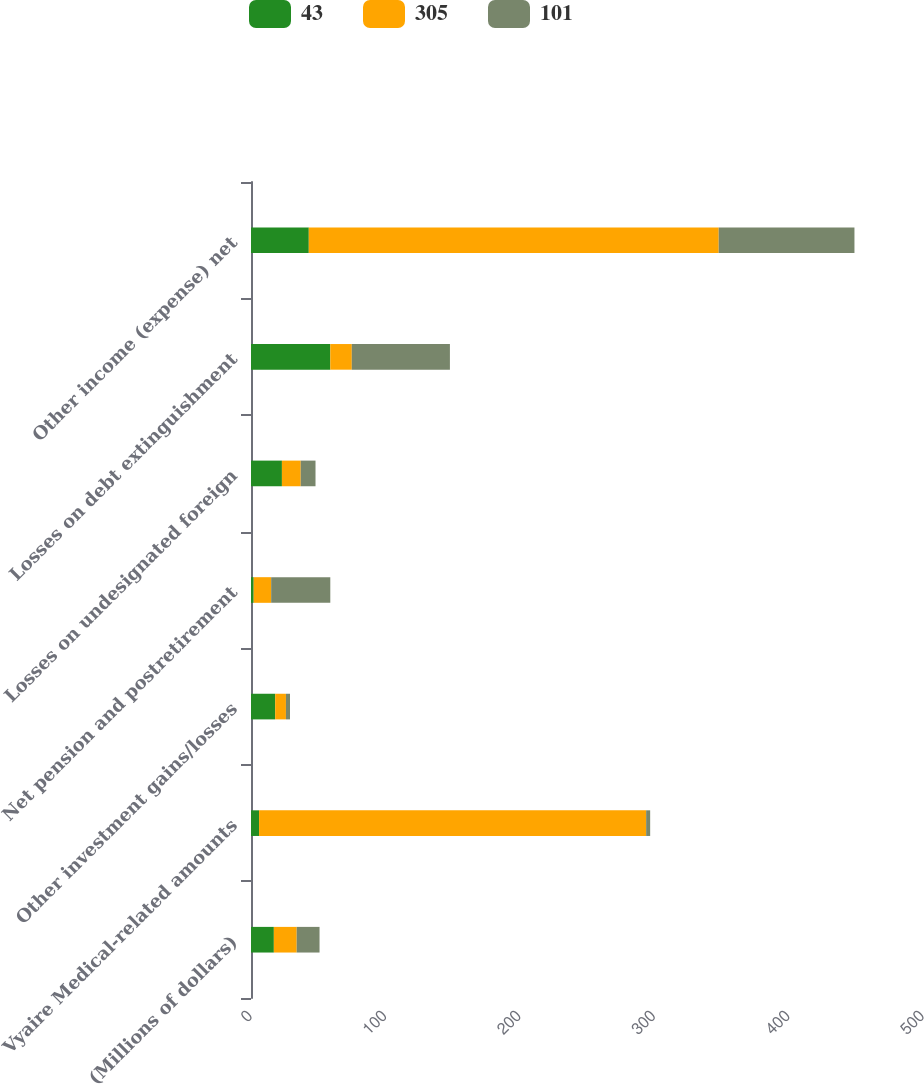Convert chart to OTSL. <chart><loc_0><loc_0><loc_500><loc_500><stacked_bar_chart><ecel><fcel>(Millions of dollars)<fcel>Vyaire Medical-related amounts<fcel>Other investment gains/losses<fcel>Net pension and postretirement<fcel>Losses on undesignated foreign<fcel>Losses on debt extinguishment<fcel>Other income (expense) net<nl><fcel>43<fcel>17<fcel>6<fcel>18<fcel>2<fcel>23<fcel>59<fcel>43<nl><fcel>305<fcel>17<fcel>288<fcel>8<fcel>13<fcel>14<fcel>16<fcel>305<nl><fcel>101<fcel>17<fcel>3<fcel>3<fcel>44<fcel>11<fcel>73<fcel>101<nl></chart> 